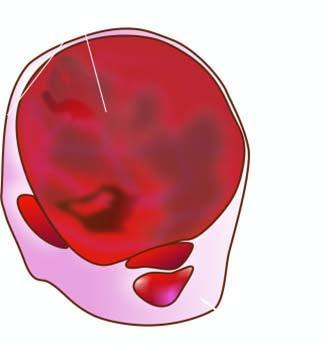does those independent of pituitary control show lobules of translucent gelatinous light brown parenchyma and areas of haemorrhage?
Answer the question using a single word or phrase. No 